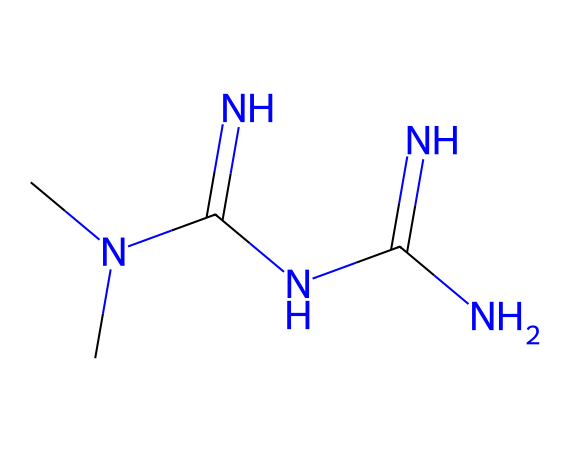What is the molecular formula of metformin? The SMILES representation CN(C)C(=N)NC(=N)N indicates the presence of carbon (C), nitrogen (N), and hydrogen (H) atoms. Counting the atoms gives us C4, H11, and N5, forming the formula C4H11N5.
Answer: C4H11N5 How many nitrogen atoms are present in metformin? From the SMILES, we can see that there are five nitrogen atoms (N) indicated in the structure.
Answer: 5 What type of compound is metformin classified as? Metformin has a structure containing multiple nitrogen atoms, which classifies it as a biguanide.
Answer: biguanide What functional groups are present in metformin? The presence of multiple amine (-NH) and imine (=N) groups indicates that the compound contains amine and imine functional groups.
Answer: amine, imine How many carbon atoms does metformin contain? Examining the SMILES notation, there are four carbon atoms (C) indicated within the structure.
Answer: 4 What is the primary therapeutic use of metformin? Metformin is primarily used for the treatment of type 2 diabetes, helping to lower blood glucose levels.
Answer: type 2 diabetes 